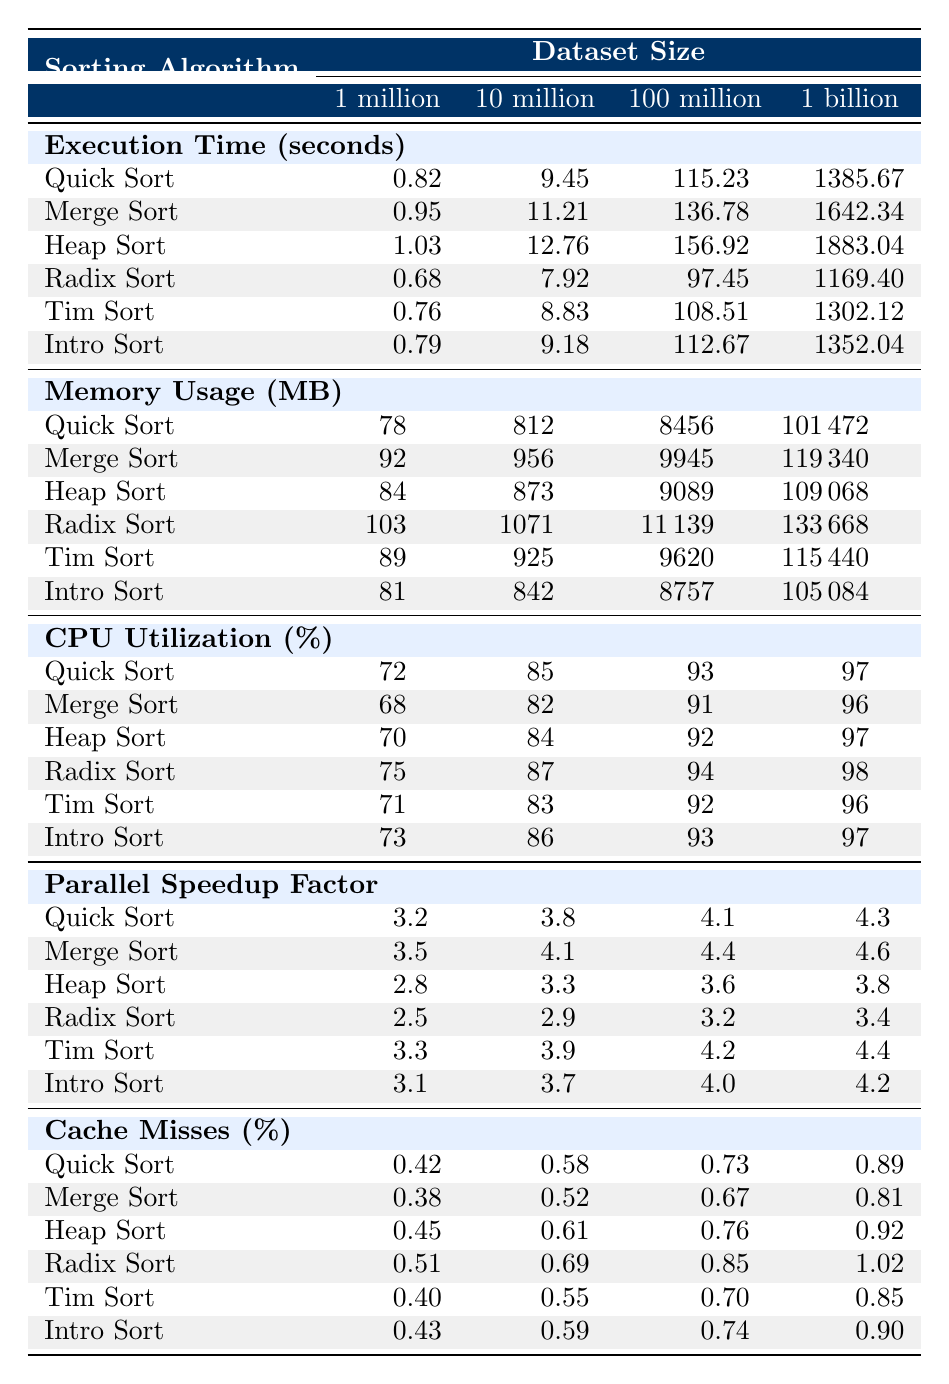What is the execution time for Quick Sort on a dataset of 10 million? By looking at the row for Quick Sort under the column for 10 million, the corresponding execution time is 9.45 seconds.
Answer: 9.45 seconds Which sorting algorithm has the highest memory usage on 1 billion records? Checking the memory usage values for each algorithm in the 1 billion column, Merge Sort has the highest value of 119340 MB.
Answer: Merge Sort What is the average CPU utilization for Heap Sort across all dataset sizes? Summing up the CPU utilization values for Heap Sort (70 + 84 + 92 + 97 = 343) and dividing by 4, the average is 343/4 = 85.75.
Answer: 85.75% Which algorithm has the best parallel speedup factor for 100 million records? Observing the values for the parallel speedup factor at 100 million, Merge Sort has the highest value of 4.4.
Answer: Merge Sort Is Radix Sort more efficient in terms of execution time compared to Tim Sort when sorting 1 billion records? For 1 billion records, Radix Sort takes 1169.40 seconds while Tim Sort takes 1302.12 seconds. Since 1169.40 < 1302.12, Radix Sort is more efficient.
Answer: Yes What is the difference in cache misses between Quick Sort and Merge Sort for a dataset size of 10 million? The cache misses for Quick Sort is 0.58% and for Merge Sort is 0.52%. The difference is 0.58% - 0.52% = 0.06%.
Answer: 0.06% Which sorting algorithm has the lowest execution time on a dataset of 1 million? The execution times for 1 million for all algorithms are compared, and we find that Radix Sort has the lowest time at 0.68 seconds.
Answer: Radix Sort How does the memory usage of Intro Sort compare with Heap Sort on 100 million records? Intro Sort uses 8757 MB while Heap Sort uses 9089 MB. Since 8757 < 9089, Intro Sort uses less memory.
Answer: Intro Sort uses less memory What is the trend in CPU utilization as the dataset size increases for Tim Sort? The CPU utilization for Tim Sort increases from 71% (1 million) to 96% (1 billion) suggesting a positive correlation with dataset size.
Answer: Increases Which algorithm shows the least increase in execution time from 1 million to 1 billion datasets? Comparing the increases in execution times from 1 million to 1 billion, Quick Sort shows the least increase of 1385.67 - 0.82 = 1384.85 seconds.
Answer: Quick Sort For which dataset size is the parallel speedup factor for Radix Sort the lowest? The parallel speedup factor for Radix Sort is compared: 2.5 (1 million), 2.9 (10 million), 3.2 (100 million), 3.4 (1 billion). The lowest is at 2.5 for 1 million.
Answer: 1 million 